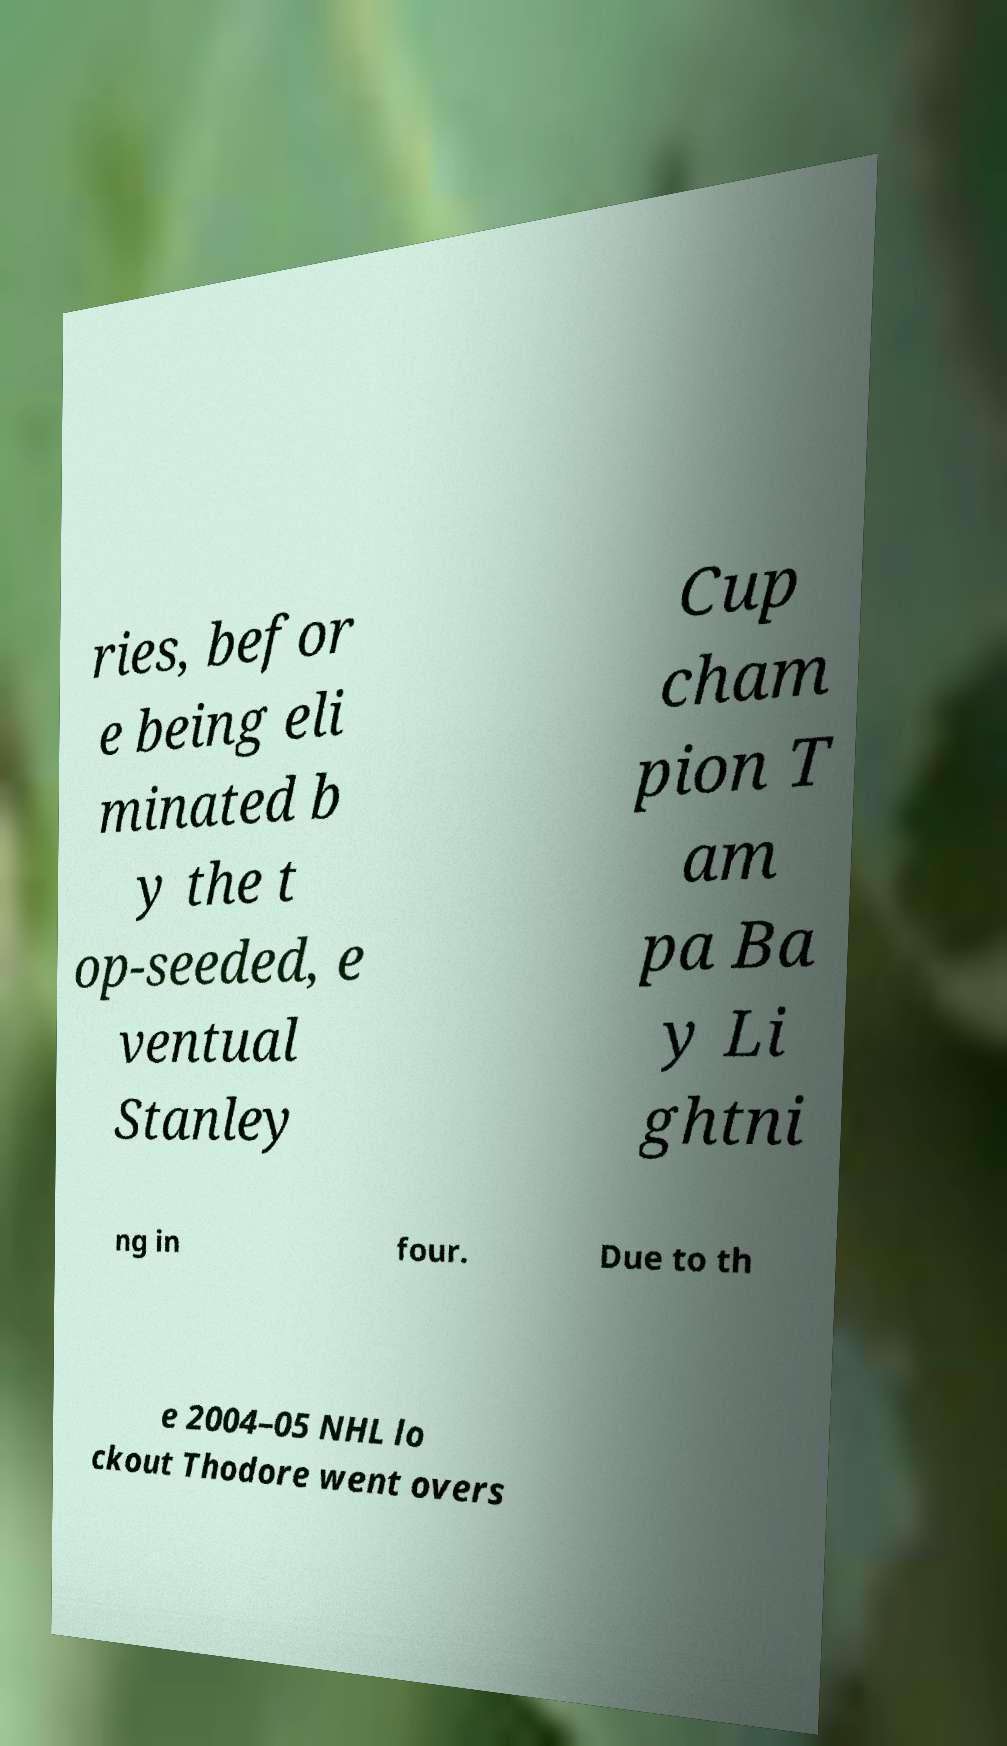Can you accurately transcribe the text from the provided image for me? ries, befor e being eli minated b y the t op-seeded, e ventual Stanley Cup cham pion T am pa Ba y Li ghtni ng in four. Due to th e 2004–05 NHL lo ckout Thodore went overs 